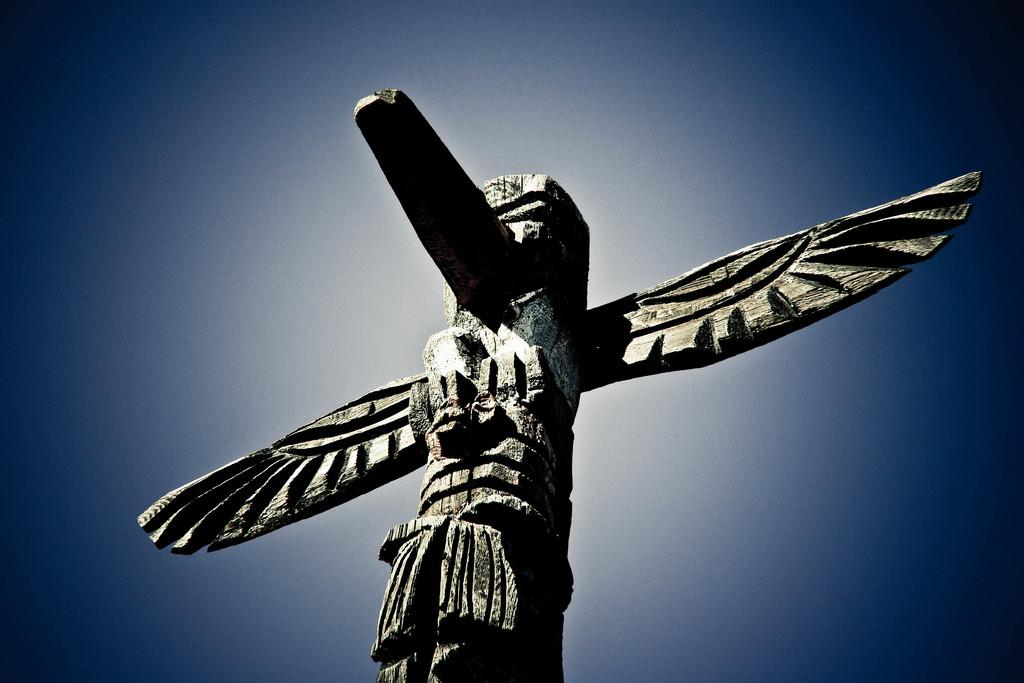What type of artwork is depicted in the image? The image is a carving sculpture. What colors are present in the background of the image? The background of the image is blue and white in color. What type of quiver is visible in the image? There is no quiver present in the image; it is a carving sculpture with a blue and white background. 